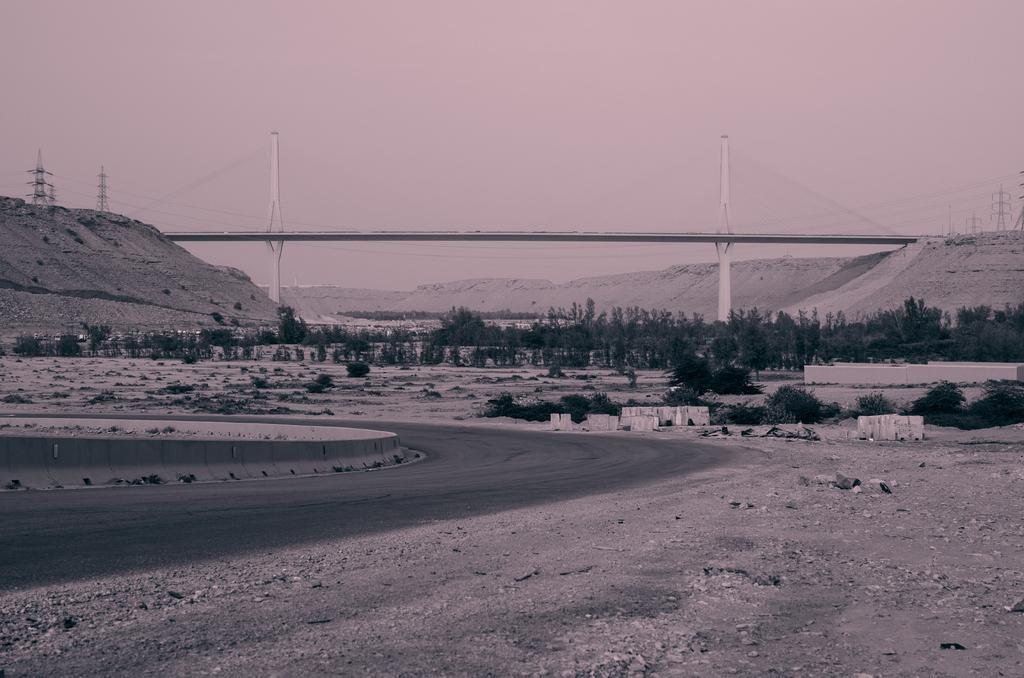What can be seen in the background of the image? There are trees, towers, and a bridge in the background of the image. What is located in the front of the image? There is a road in the front of the image. What type of surface is on the ground in the front of the image? There are stones on the ground in the front of the image. How many frogs are hopping on the plot of land in the image? There is no plot of land or frogs present in the image. What type of laborer can be seen working on the bridge in the image? There are no laborers or any indication of work being done on the bridge in the image. 